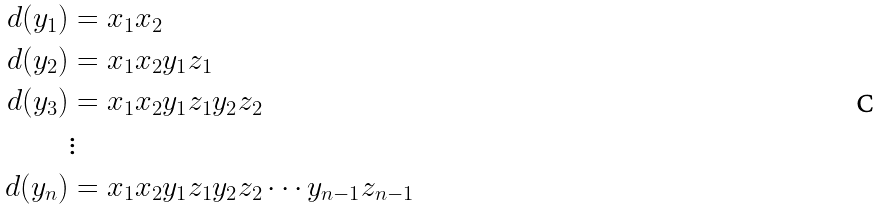Convert formula to latex. <formula><loc_0><loc_0><loc_500><loc_500>d ( y _ { 1 } ) & = x _ { 1 } x _ { 2 } \\ d ( y _ { 2 } ) & = x _ { 1 } x _ { 2 } y _ { 1 } z _ { 1 } \\ d ( y _ { 3 } ) & = x _ { 1 } x _ { 2 } y _ { 1 } z _ { 1 } y _ { 2 } z _ { 2 } \\ & \vdots \\ d ( y _ { n } ) & = x _ { 1 } x _ { 2 } y _ { 1 } z _ { 1 } y _ { 2 } z _ { 2 } \cdots y _ { n - 1 } z _ { n - 1 }</formula> 